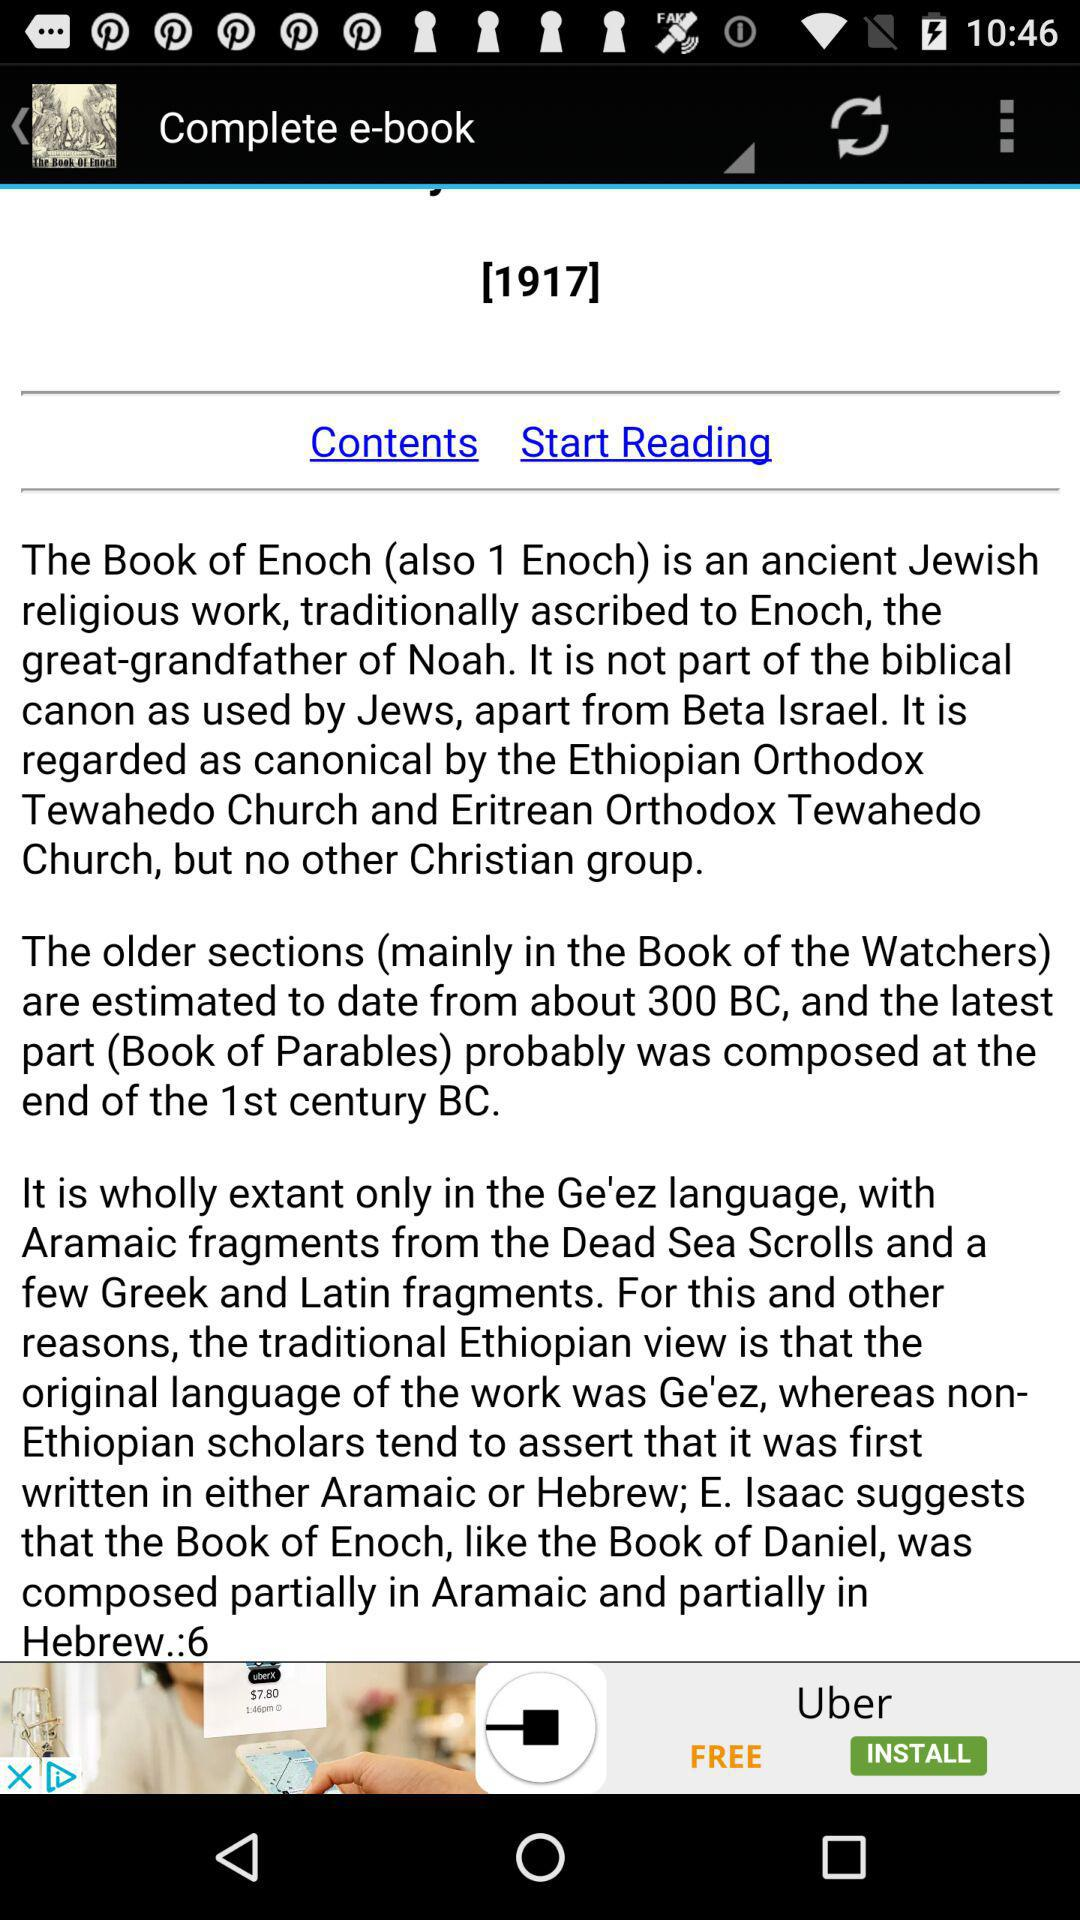What is the given year?
When the provided information is insufficient, respond with <no answer>. <no answer> 